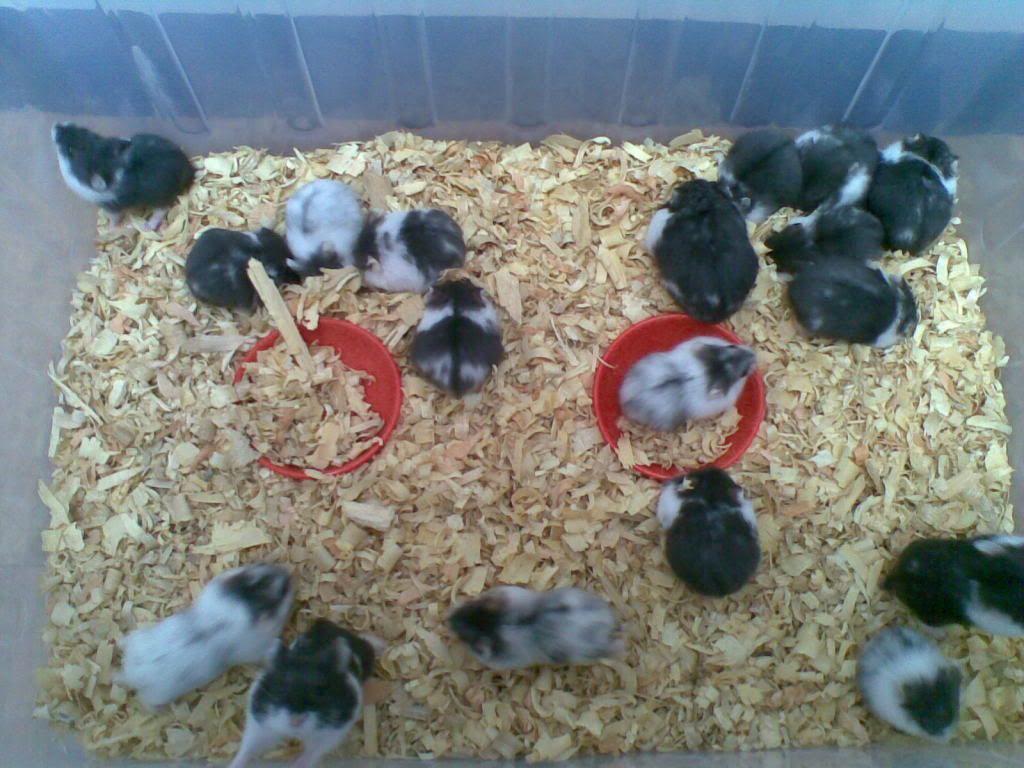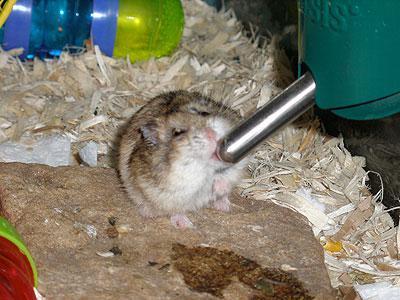The first image is the image on the left, the second image is the image on the right. Analyze the images presented: Is the assertion "There are exactly two hamsters" valid? Answer yes or no. No. The first image is the image on the left, the second image is the image on the right. For the images shown, is this caption "There are two mice." true? Answer yes or no. No. 